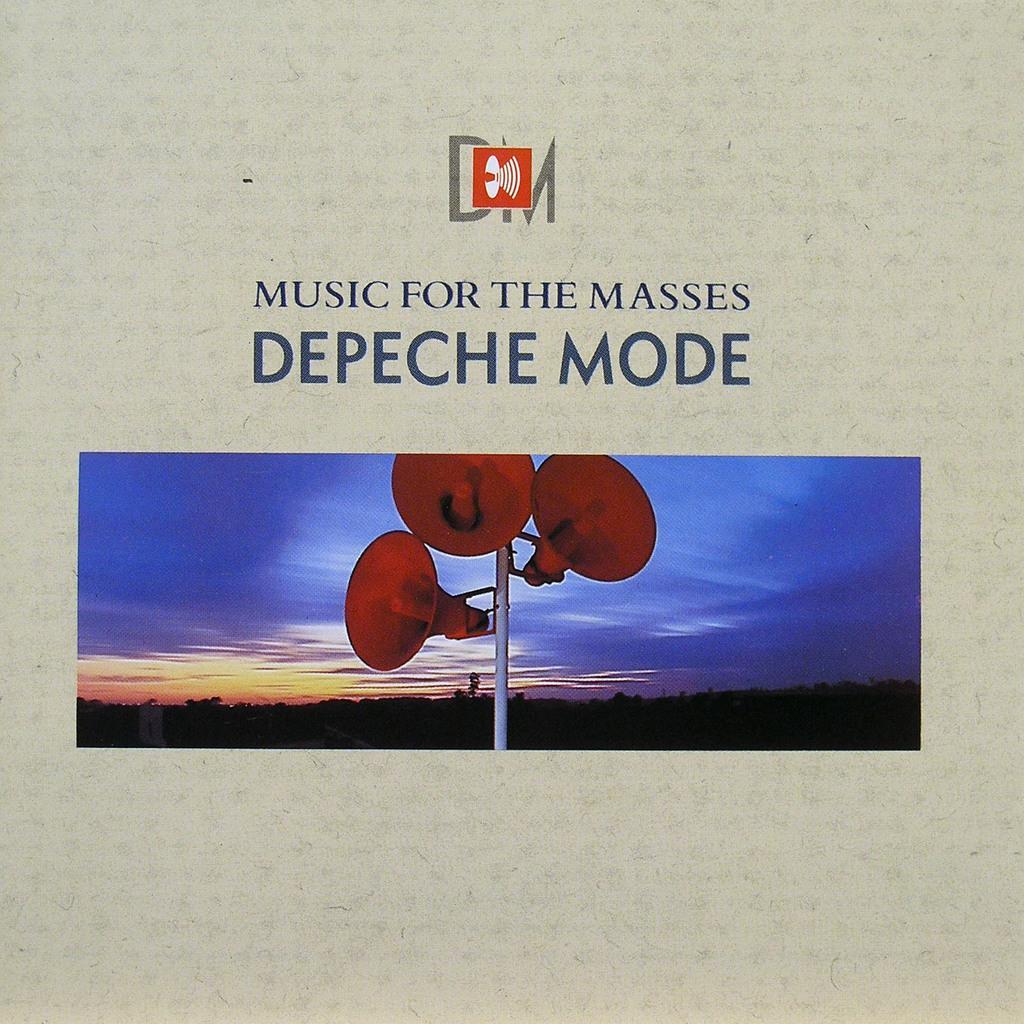In one or two sentences, can you explain what this image depicts? This image consists of a poster. In which we can see a pole to which there are three speakers. In the background, there are trees. At the top, there is sky in blue color. At the top, there is a text. 